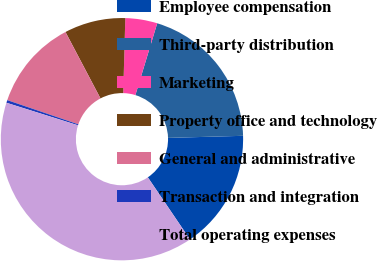Convert chart to OTSL. <chart><loc_0><loc_0><loc_500><loc_500><pie_chart><fcel>Employee compensation<fcel>Third-party distribution<fcel>Marketing<fcel>Property office and technology<fcel>General and administrative<fcel>Transaction and integration<fcel>Total operating expenses<nl><fcel>15.96%<fcel>19.86%<fcel>4.26%<fcel>8.16%<fcel>12.06%<fcel>0.36%<fcel>39.35%<nl></chart> 